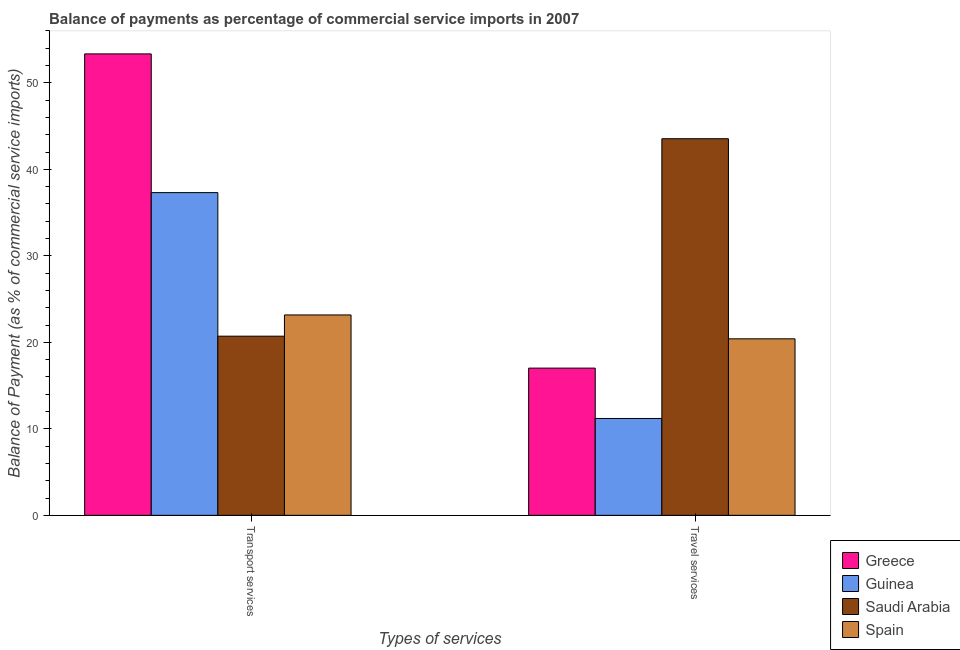Are the number of bars per tick equal to the number of legend labels?
Your response must be concise. Yes. Are the number of bars on each tick of the X-axis equal?
Provide a succinct answer. Yes. How many bars are there on the 1st tick from the left?
Provide a succinct answer. 4. How many bars are there on the 2nd tick from the right?
Give a very brief answer. 4. What is the label of the 1st group of bars from the left?
Your answer should be very brief. Transport services. What is the balance of payments of transport services in Guinea?
Your answer should be compact. 37.31. Across all countries, what is the maximum balance of payments of transport services?
Ensure brevity in your answer.  53.34. Across all countries, what is the minimum balance of payments of travel services?
Keep it short and to the point. 11.2. In which country was the balance of payments of transport services maximum?
Offer a very short reply. Greece. In which country was the balance of payments of travel services minimum?
Offer a very short reply. Guinea. What is the total balance of payments of transport services in the graph?
Make the answer very short. 134.52. What is the difference between the balance of payments of transport services in Greece and that in Saudi Arabia?
Offer a very short reply. 32.63. What is the difference between the balance of payments of transport services in Greece and the balance of payments of travel services in Guinea?
Offer a very short reply. 42.14. What is the average balance of payments of transport services per country?
Your answer should be very brief. 33.63. What is the difference between the balance of payments of transport services and balance of payments of travel services in Greece?
Provide a succinct answer. 36.32. In how many countries, is the balance of payments of transport services greater than 22 %?
Ensure brevity in your answer.  3. What is the ratio of the balance of payments of transport services in Greece to that in Spain?
Give a very brief answer. 2.3. Is the balance of payments of transport services in Saudi Arabia less than that in Guinea?
Provide a short and direct response. Yes. In how many countries, is the balance of payments of transport services greater than the average balance of payments of transport services taken over all countries?
Your answer should be very brief. 2. How many bars are there?
Give a very brief answer. 8. Are all the bars in the graph horizontal?
Give a very brief answer. No. Are the values on the major ticks of Y-axis written in scientific E-notation?
Make the answer very short. No. Does the graph contain any zero values?
Keep it short and to the point. No. Does the graph contain grids?
Provide a short and direct response. No. Where does the legend appear in the graph?
Make the answer very short. Bottom right. How many legend labels are there?
Offer a terse response. 4. What is the title of the graph?
Your response must be concise. Balance of payments as percentage of commercial service imports in 2007. Does "Mongolia" appear as one of the legend labels in the graph?
Provide a succinct answer. No. What is the label or title of the X-axis?
Your response must be concise. Types of services. What is the label or title of the Y-axis?
Offer a terse response. Balance of Payment (as % of commercial service imports). What is the Balance of Payment (as % of commercial service imports) of Greece in Transport services?
Provide a succinct answer. 53.34. What is the Balance of Payment (as % of commercial service imports) in Guinea in Transport services?
Provide a short and direct response. 37.31. What is the Balance of Payment (as % of commercial service imports) of Saudi Arabia in Transport services?
Provide a short and direct response. 20.71. What is the Balance of Payment (as % of commercial service imports) of Spain in Transport services?
Keep it short and to the point. 23.16. What is the Balance of Payment (as % of commercial service imports) in Greece in Travel services?
Offer a terse response. 17.02. What is the Balance of Payment (as % of commercial service imports) of Guinea in Travel services?
Give a very brief answer. 11.2. What is the Balance of Payment (as % of commercial service imports) in Saudi Arabia in Travel services?
Give a very brief answer. 43.53. What is the Balance of Payment (as % of commercial service imports) in Spain in Travel services?
Provide a short and direct response. 20.4. Across all Types of services, what is the maximum Balance of Payment (as % of commercial service imports) in Greece?
Your answer should be compact. 53.34. Across all Types of services, what is the maximum Balance of Payment (as % of commercial service imports) in Guinea?
Your response must be concise. 37.31. Across all Types of services, what is the maximum Balance of Payment (as % of commercial service imports) in Saudi Arabia?
Make the answer very short. 43.53. Across all Types of services, what is the maximum Balance of Payment (as % of commercial service imports) of Spain?
Offer a very short reply. 23.16. Across all Types of services, what is the minimum Balance of Payment (as % of commercial service imports) in Greece?
Your response must be concise. 17.02. Across all Types of services, what is the minimum Balance of Payment (as % of commercial service imports) in Guinea?
Make the answer very short. 11.2. Across all Types of services, what is the minimum Balance of Payment (as % of commercial service imports) in Saudi Arabia?
Your answer should be compact. 20.71. Across all Types of services, what is the minimum Balance of Payment (as % of commercial service imports) in Spain?
Keep it short and to the point. 20.4. What is the total Balance of Payment (as % of commercial service imports) in Greece in the graph?
Give a very brief answer. 70.36. What is the total Balance of Payment (as % of commercial service imports) of Guinea in the graph?
Your answer should be very brief. 48.5. What is the total Balance of Payment (as % of commercial service imports) of Saudi Arabia in the graph?
Make the answer very short. 64.24. What is the total Balance of Payment (as % of commercial service imports) of Spain in the graph?
Make the answer very short. 43.57. What is the difference between the Balance of Payment (as % of commercial service imports) in Greece in Transport services and that in Travel services?
Offer a terse response. 36.32. What is the difference between the Balance of Payment (as % of commercial service imports) in Guinea in Transport services and that in Travel services?
Give a very brief answer. 26.11. What is the difference between the Balance of Payment (as % of commercial service imports) in Saudi Arabia in Transport services and that in Travel services?
Make the answer very short. -22.82. What is the difference between the Balance of Payment (as % of commercial service imports) of Spain in Transport services and that in Travel services?
Your answer should be compact. 2.76. What is the difference between the Balance of Payment (as % of commercial service imports) in Greece in Transport services and the Balance of Payment (as % of commercial service imports) in Guinea in Travel services?
Give a very brief answer. 42.14. What is the difference between the Balance of Payment (as % of commercial service imports) in Greece in Transport services and the Balance of Payment (as % of commercial service imports) in Saudi Arabia in Travel services?
Provide a succinct answer. 9.81. What is the difference between the Balance of Payment (as % of commercial service imports) of Greece in Transport services and the Balance of Payment (as % of commercial service imports) of Spain in Travel services?
Provide a short and direct response. 32.94. What is the difference between the Balance of Payment (as % of commercial service imports) in Guinea in Transport services and the Balance of Payment (as % of commercial service imports) in Saudi Arabia in Travel services?
Ensure brevity in your answer.  -6.23. What is the difference between the Balance of Payment (as % of commercial service imports) of Guinea in Transport services and the Balance of Payment (as % of commercial service imports) of Spain in Travel services?
Offer a terse response. 16.9. What is the difference between the Balance of Payment (as % of commercial service imports) in Saudi Arabia in Transport services and the Balance of Payment (as % of commercial service imports) in Spain in Travel services?
Provide a succinct answer. 0.31. What is the average Balance of Payment (as % of commercial service imports) of Greece per Types of services?
Give a very brief answer. 35.18. What is the average Balance of Payment (as % of commercial service imports) of Guinea per Types of services?
Offer a very short reply. 24.25. What is the average Balance of Payment (as % of commercial service imports) in Saudi Arabia per Types of services?
Give a very brief answer. 32.12. What is the average Balance of Payment (as % of commercial service imports) in Spain per Types of services?
Keep it short and to the point. 21.78. What is the difference between the Balance of Payment (as % of commercial service imports) of Greece and Balance of Payment (as % of commercial service imports) of Guinea in Transport services?
Offer a terse response. 16.03. What is the difference between the Balance of Payment (as % of commercial service imports) of Greece and Balance of Payment (as % of commercial service imports) of Saudi Arabia in Transport services?
Provide a succinct answer. 32.63. What is the difference between the Balance of Payment (as % of commercial service imports) of Greece and Balance of Payment (as % of commercial service imports) of Spain in Transport services?
Offer a very short reply. 30.18. What is the difference between the Balance of Payment (as % of commercial service imports) in Guinea and Balance of Payment (as % of commercial service imports) in Saudi Arabia in Transport services?
Offer a terse response. 16.6. What is the difference between the Balance of Payment (as % of commercial service imports) of Guinea and Balance of Payment (as % of commercial service imports) of Spain in Transport services?
Provide a succinct answer. 14.14. What is the difference between the Balance of Payment (as % of commercial service imports) of Saudi Arabia and Balance of Payment (as % of commercial service imports) of Spain in Transport services?
Provide a short and direct response. -2.45. What is the difference between the Balance of Payment (as % of commercial service imports) in Greece and Balance of Payment (as % of commercial service imports) in Guinea in Travel services?
Keep it short and to the point. 5.82. What is the difference between the Balance of Payment (as % of commercial service imports) in Greece and Balance of Payment (as % of commercial service imports) in Saudi Arabia in Travel services?
Make the answer very short. -26.52. What is the difference between the Balance of Payment (as % of commercial service imports) of Greece and Balance of Payment (as % of commercial service imports) of Spain in Travel services?
Provide a short and direct response. -3.39. What is the difference between the Balance of Payment (as % of commercial service imports) in Guinea and Balance of Payment (as % of commercial service imports) in Saudi Arabia in Travel services?
Your response must be concise. -32.34. What is the difference between the Balance of Payment (as % of commercial service imports) in Guinea and Balance of Payment (as % of commercial service imports) in Spain in Travel services?
Offer a terse response. -9.21. What is the difference between the Balance of Payment (as % of commercial service imports) of Saudi Arabia and Balance of Payment (as % of commercial service imports) of Spain in Travel services?
Provide a short and direct response. 23.13. What is the ratio of the Balance of Payment (as % of commercial service imports) in Greece in Transport services to that in Travel services?
Keep it short and to the point. 3.13. What is the ratio of the Balance of Payment (as % of commercial service imports) of Guinea in Transport services to that in Travel services?
Make the answer very short. 3.33. What is the ratio of the Balance of Payment (as % of commercial service imports) in Saudi Arabia in Transport services to that in Travel services?
Your answer should be compact. 0.48. What is the ratio of the Balance of Payment (as % of commercial service imports) of Spain in Transport services to that in Travel services?
Give a very brief answer. 1.14. What is the difference between the highest and the second highest Balance of Payment (as % of commercial service imports) in Greece?
Keep it short and to the point. 36.32. What is the difference between the highest and the second highest Balance of Payment (as % of commercial service imports) in Guinea?
Give a very brief answer. 26.11. What is the difference between the highest and the second highest Balance of Payment (as % of commercial service imports) in Saudi Arabia?
Your response must be concise. 22.82. What is the difference between the highest and the second highest Balance of Payment (as % of commercial service imports) in Spain?
Keep it short and to the point. 2.76. What is the difference between the highest and the lowest Balance of Payment (as % of commercial service imports) of Greece?
Your answer should be compact. 36.32. What is the difference between the highest and the lowest Balance of Payment (as % of commercial service imports) of Guinea?
Offer a terse response. 26.11. What is the difference between the highest and the lowest Balance of Payment (as % of commercial service imports) of Saudi Arabia?
Your response must be concise. 22.82. What is the difference between the highest and the lowest Balance of Payment (as % of commercial service imports) of Spain?
Offer a very short reply. 2.76. 